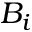<formula> <loc_0><loc_0><loc_500><loc_500>B _ { i }</formula> 